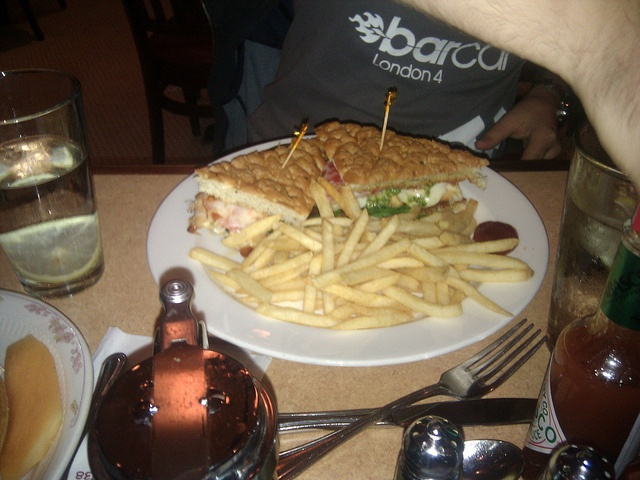Describe the objects in this image and their specific colors. I can see people in black, darkgray, and tan tones, dining table in black, tan, and gray tones, cup in black and gray tones, bottle in black, maroon, and gray tones, and chair in black and darkgreen tones in this image. 